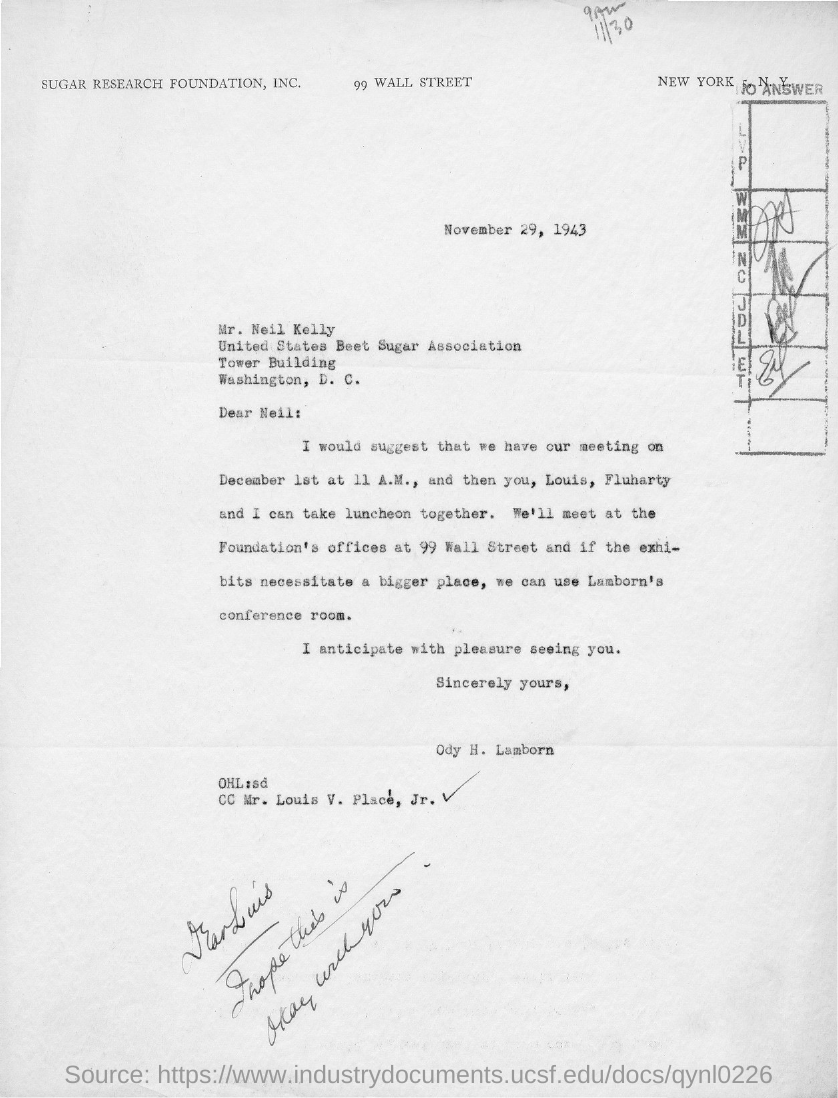Mention a couple of crucial points in this snapshot. The addressee of this letter is Neil. The issued date of this letter is November 29, 1943. The recipient of this letter is marked as 'Mr. Louis V. Place, Jr.' in the cc field. The sender of this letter is Odysseus H. Lamborn. 